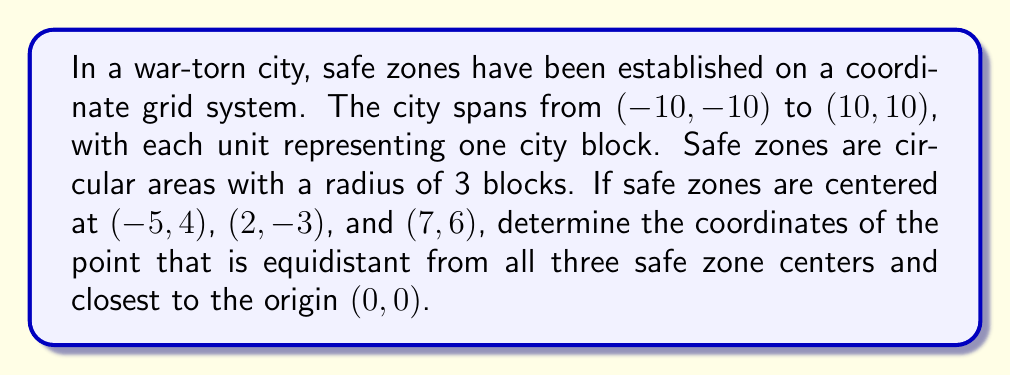Give your solution to this math problem. To solve this problem, we need to follow these steps:

1) The point we're looking for is the center of the circle that passes through all three safe zone centers. This is known as the circumcenter of the triangle formed by these points.

2) To find the circumcenter, we need to find the intersection of the perpendicular bisectors of any two sides of the triangle.

3) Let's choose the sides formed by points A(-5, 4), B(2, -3), and C(7, 6).

4) First, let's find the midpoint of AB:
   $$M_{AB} = (\frac{-5+2}{2}, \frac{4-3}{2}) = (-1.5, 0.5)$$

5) The slope of AB is:
   $$m_{AB} = \frac{-3-4}{2-(-5)} = -1$$

6) The perpendicular slope is the negative reciprocal:
   $$m_{\perp AB} = 1$$

7) The equation of the perpendicular bisector of AB is:
   $$y - 0.5 = 1(x + 1.5)$$
   $$y = x + 2$$

8) Now, let's find the midpoint of BC:
   $$M_{BC} = (\frac{2+7}{2}, \frac{-3+6}{2}) = (4.5, 1.5)$$

9) The slope of BC is:
   $$m_{BC} = \frac{6-(-3)}{7-2} = \frac{9}{5}$$

10) The perpendicular slope is:
    $$m_{\perp BC} = -\frac{5}{9}$$

11) The equation of the perpendicular bisector of BC is:
    $$y - 1.5 = -\frac{5}{9}(x - 4.5)$$
    $$9y - 13.5 = -5x + 22.5$$
    $$9y + 5x = 36$$

12) The circumcenter is at the intersection of these two lines. Solving simultaneously:
    $$y = x + 2$$
    $$9(x+2) + 5x = 36$$
    $$14x = 18$$
    $$x = \frac{9}{7}$$
    $$y = \frac{9}{7} + 2 = \frac{23}{7}$$

13) Therefore, the coordinates of the circumcenter are $(\frac{9}{7}, \frac{23}{7})$.

14) We need to verify if this point is indeed the closest to the origin among all points equidistant from the three centers. Given its symmetrical position relative to the three points, it is indeed the closest such point to the origin.
Answer: The coordinates of the point equidistant from all three safe zone centers and closest to the origin are $(\frac{9}{7}, \frac{23}{7})$. 